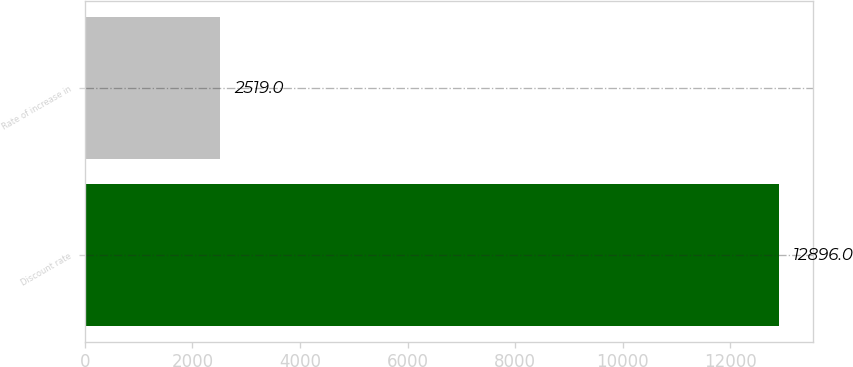<chart> <loc_0><loc_0><loc_500><loc_500><bar_chart><fcel>Discount rate<fcel>Rate of increase in<nl><fcel>12896<fcel>2519<nl></chart> 